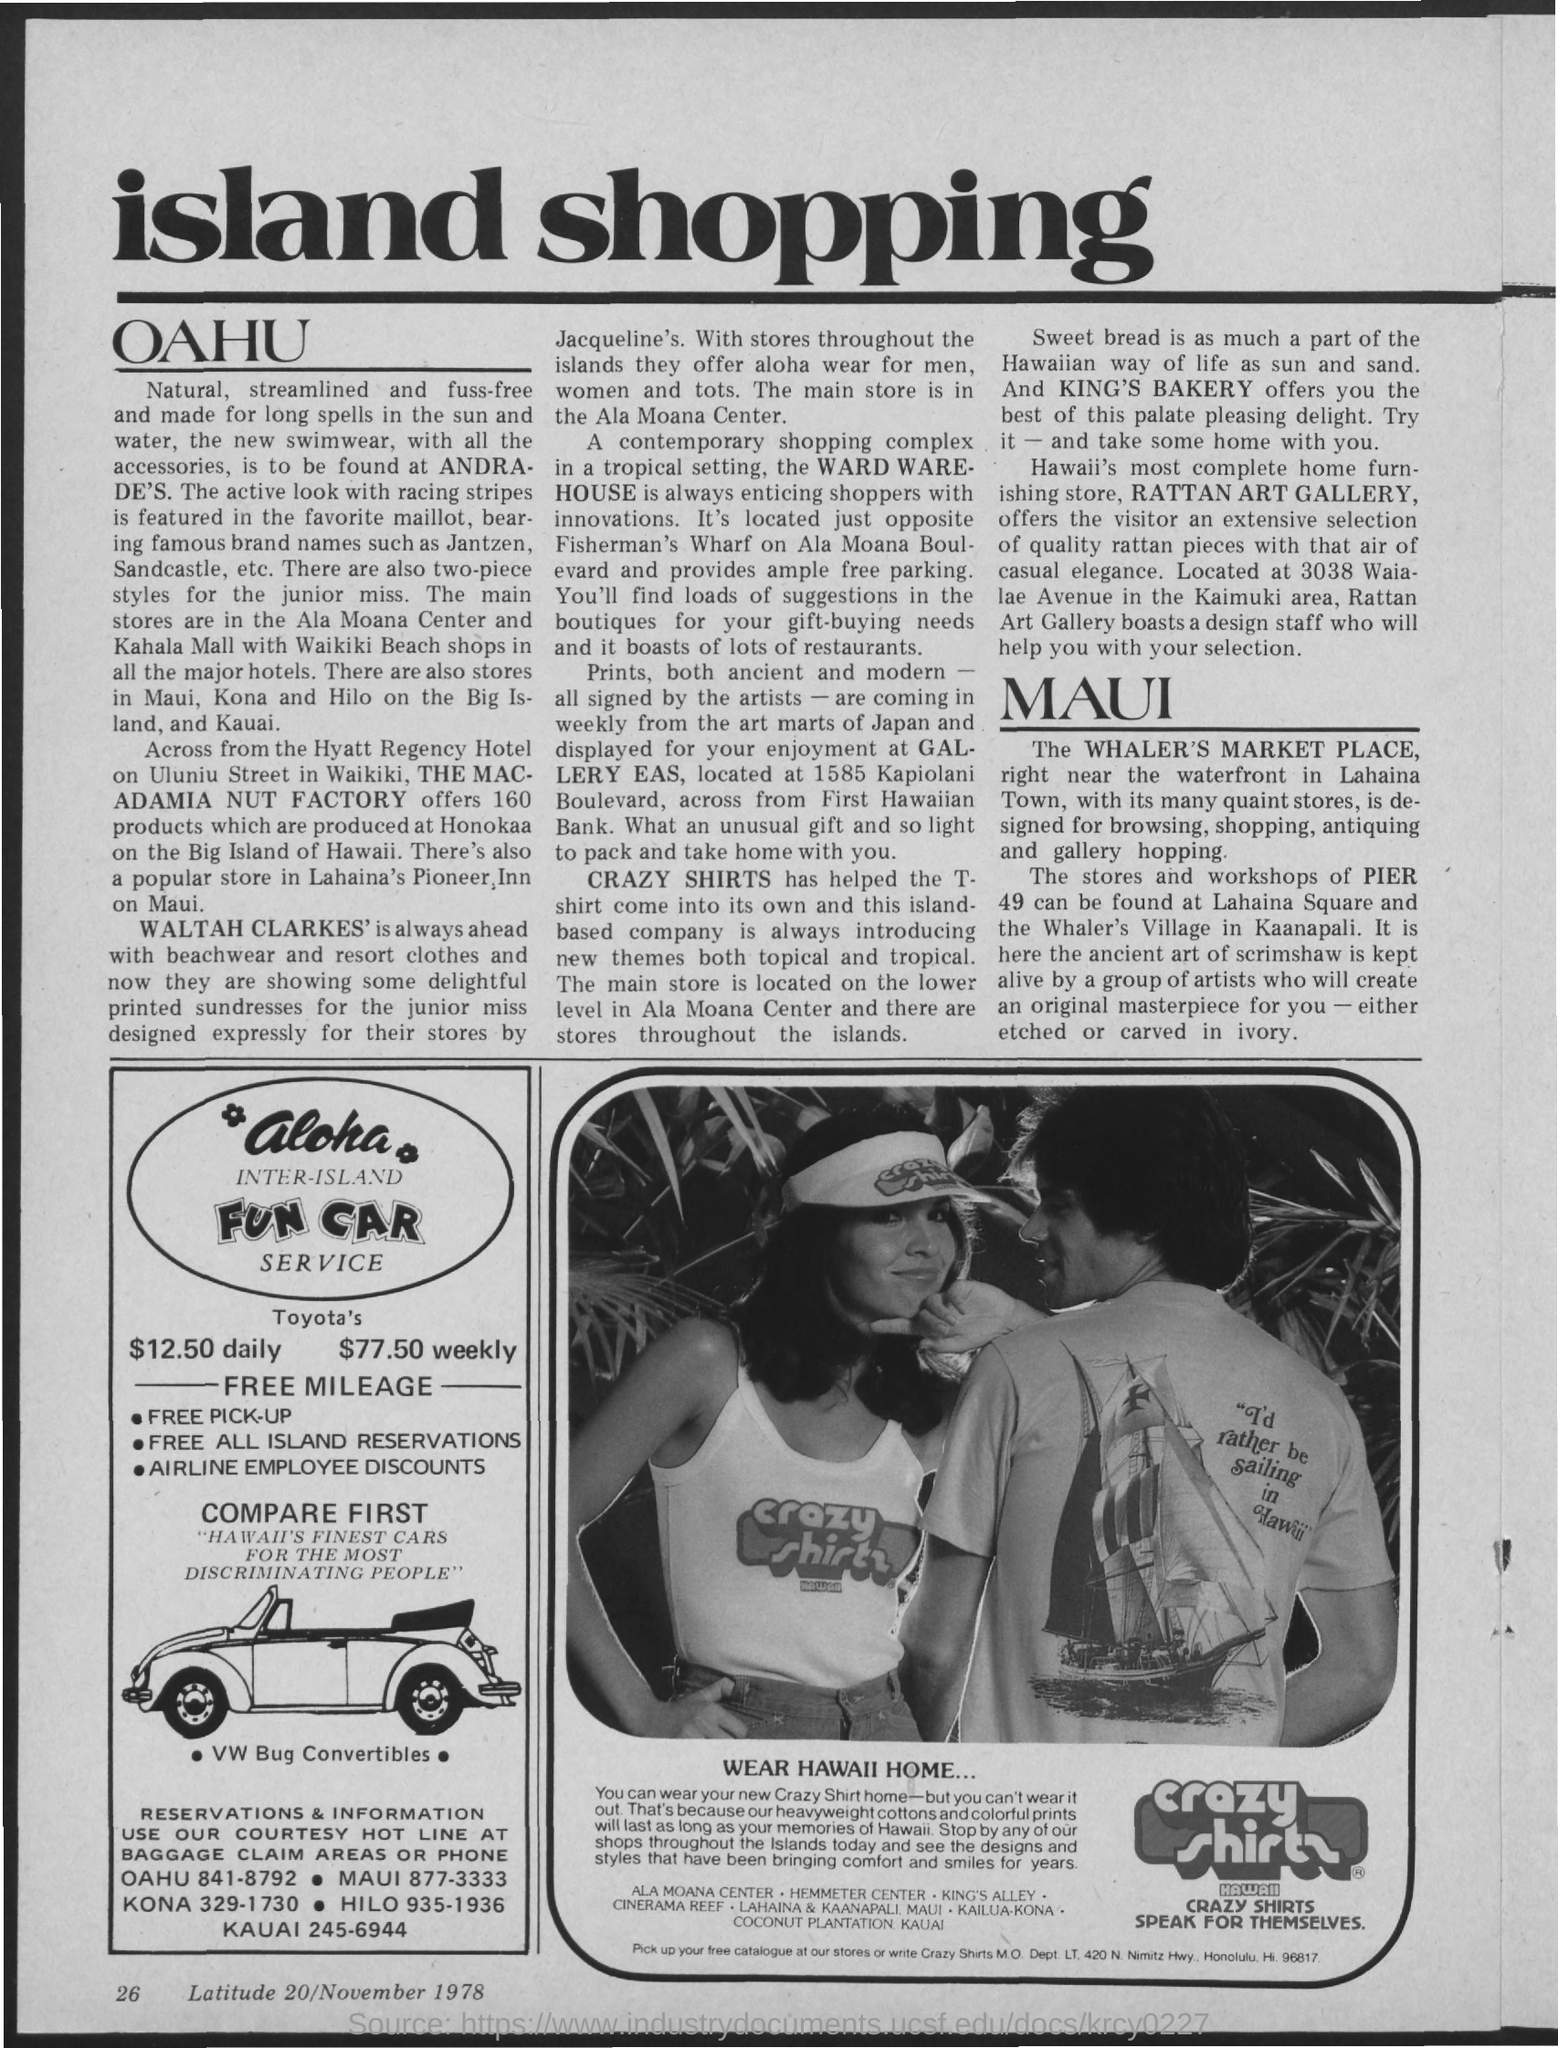Give some essential details in this illustration. The heading of the document on top of the page is "Island Shopping. The postal address of Crazy Shirts is located at 420 N. Nimitz Highway, Honolulu, Hawaii 96817. The postal code for the state of HI is 96817. 